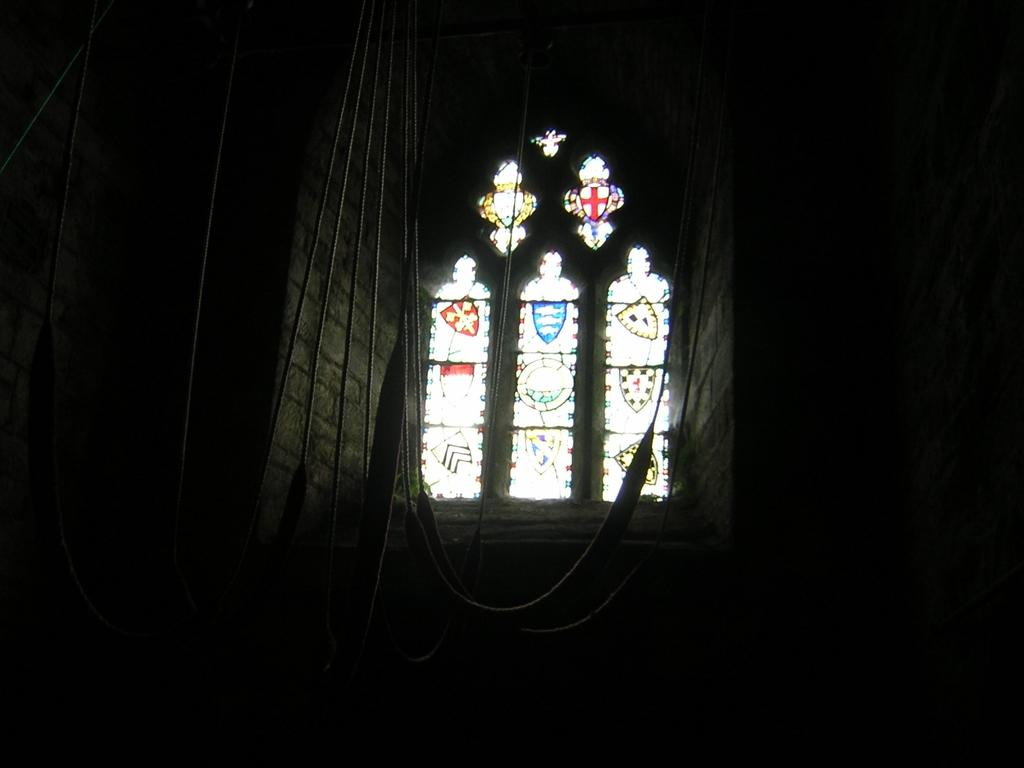What can be seen on the windows in the image? There is a design on the windows in the image. How many windows are visible in the image? The number of windows is not specified, but there are windows present in the image. What can be observed about the corners of the image? The corners of the image are dark. What type of pen is being used to draw the design on the windows in the image? There is no pen or drawing process visible in the image; the design is already present on the windows. 